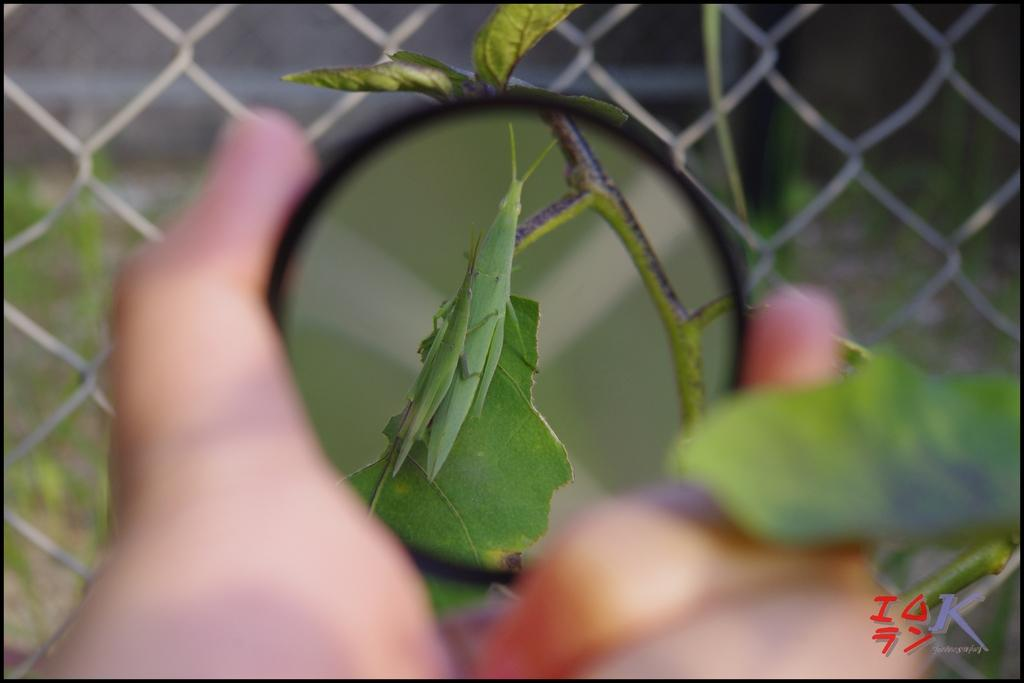What object is being held by the person's hand in the image? There is a person's hand holding a magnifying glass in the image. What is the magnifying glass being used to observe in the image? A leaf is visible through the magnifying glass. What type of fencing can be seen in the background of the image? There is iron fencing in the background of the image. What type of wood can be seen in the image? There is no wood present in the image; it features a person's hand holding a magnifying glass and a leaf being observed through it, with iron fencing in the background. 